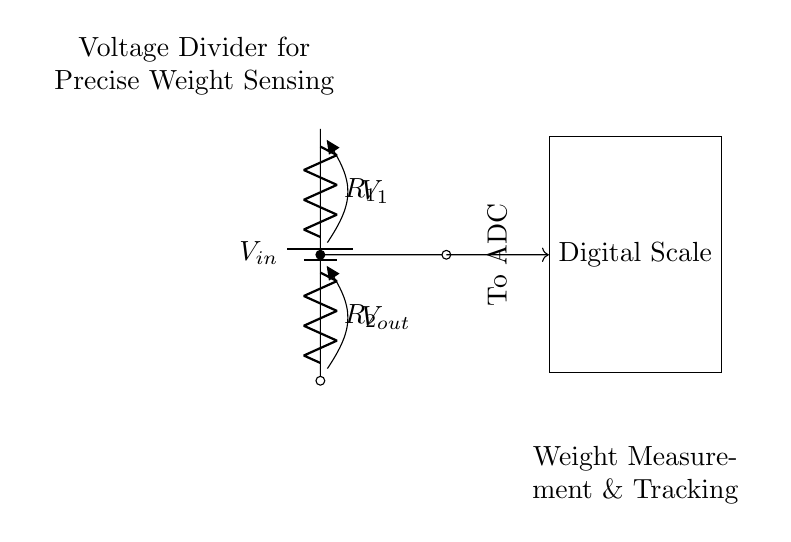What is the input voltage in this circuit? The input voltage (denoted as Vin) is the voltage supplied to the battery in the diagram. It is shown at the top of the circuit.
Answer: Vin What are the resistances shown in the circuit? The circuit shows two resistors, R1 and R2, which are connected in series as part of the voltage divider.
Answer: R1, R2 What is the output voltage labeled as? The output voltage is labeled as Vout, which is the voltage dropped across R2 in this voltage divider configuration.
Answer: Vout How does Vout relate to Vin in a voltage divider? Vout is calculated using the formula Vout = Vin * (R2 / (R1 + R2)). This indicates that Vout is a fraction of Vin determined by the resistor values.
Answer: Vout = Vin * (R2 / (R1 + R2)) What component does the output connect to next? The output Vout connects to an Analog-to-Digital Converter (ADC), which is represented by the arrow labeled "To ADC" in the diagram.
Answer: ADC What function does this voltage divider serve on the digital scale? The voltage divider is used for precise weight measurement and tracking by providing a scaled-down voltage that corresponds to the weight.
Answer: Weight measurement What does the voltage divider allow for in terms of measurements? The voltage divider allows for accurate measurement of weight by converting the analog voltage drop into a digital signal that can be processed by the ADC in the digital scale.
Answer: Accurate weight measurement 